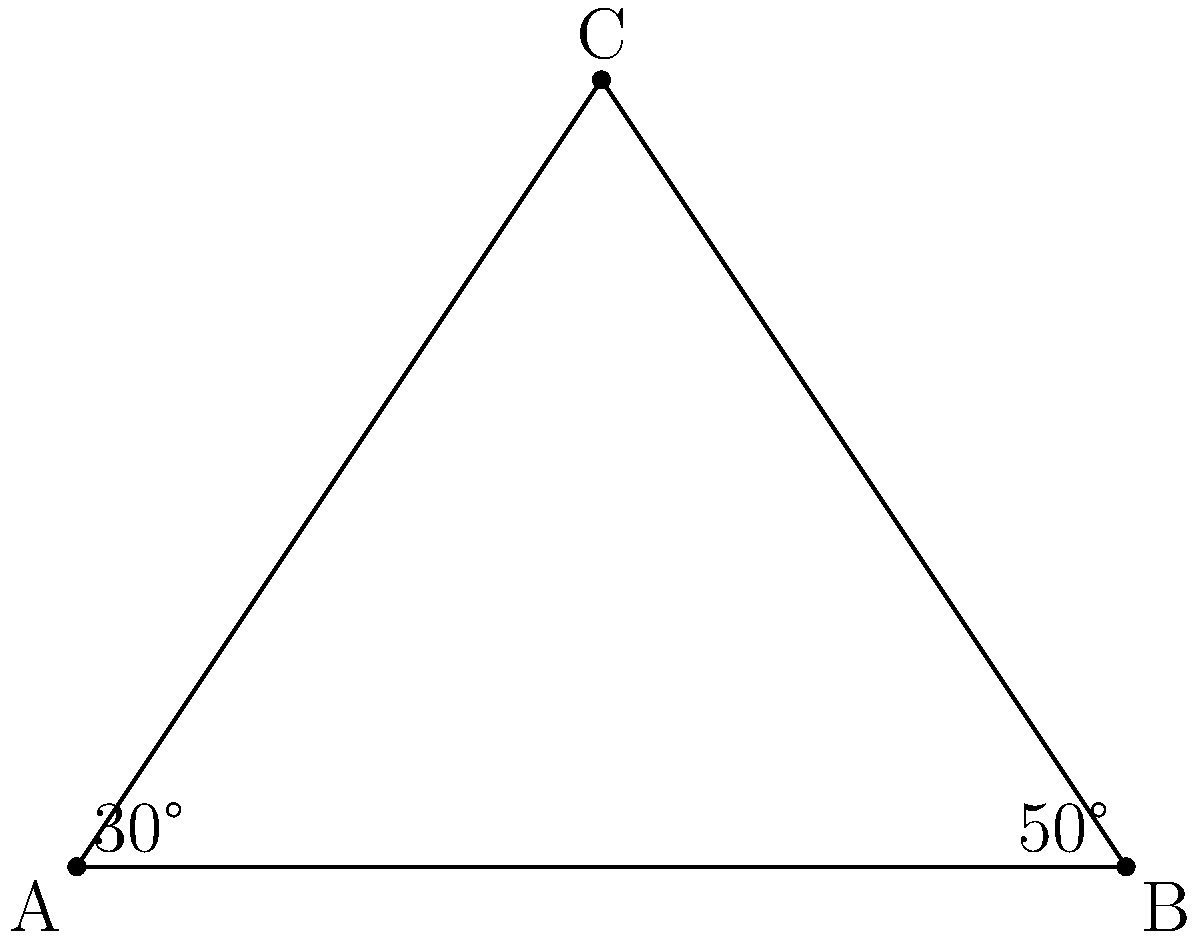In a Greek revolutionary camp near Tripolitsa, Theodoros Kolokotronis is planning the layout of the camp. He sketches a triangular formation ABC, where AB represents the frontline facing the Ottoman forces. If the angle at A is 30° and the angle at B is 50°, what is the measure of angle ACB? To solve this problem, we'll use the properties of triangles:

1. In any triangle, the sum of all interior angles is always 180°.

2. Let's denote the angle at C as x°.

3. We can set up an equation based on the fact that the sum of all angles in a triangle is 180°:
   
   $30° + 50° + x° = 180°$

4. Simplify the left side of the equation:
   
   $80° + x° = 180°$

5. Subtract 80° from both sides:
   
   $x° = 180° - 80° = 100°$

Therefore, the measure of angle ACB is 100°.
Answer: 100° 